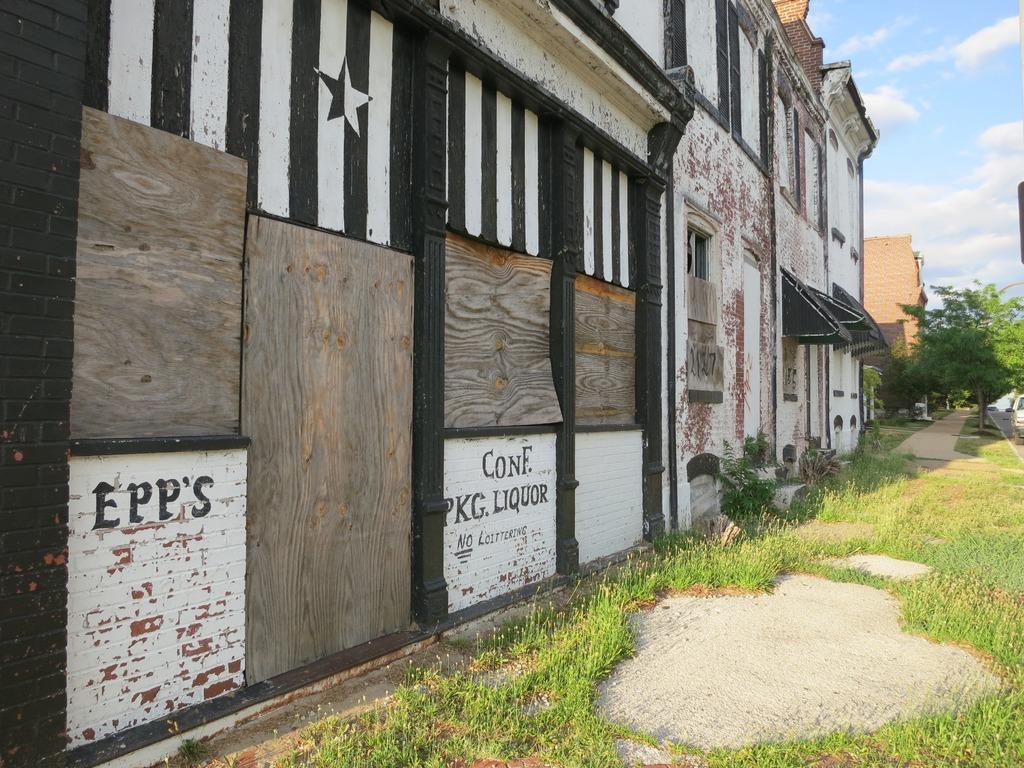In one or two sentences, can you explain what this image depicts? In this image there are buildings. Right side there is a vehicle on the road. There are trees and plants on the land having grass. Right side there is a path. Right top there is sky having clouds. There is some text painted on the wall of a building. 